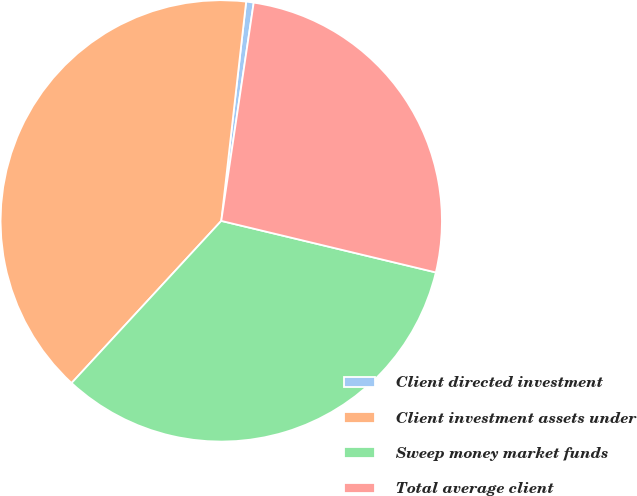<chart> <loc_0><loc_0><loc_500><loc_500><pie_chart><fcel>Client directed investment<fcel>Client investment assets under<fcel>Sweep money market funds<fcel>Total average client<nl><fcel>0.55%<fcel>39.93%<fcel>33.11%<fcel>26.4%<nl></chart> 